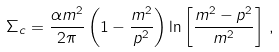<formula> <loc_0><loc_0><loc_500><loc_500>\Sigma _ { c } = \frac { \alpha m ^ { 2 } } { 2 \pi } \left ( 1 - \frac { m ^ { 2 } } { p ^ { 2 } } \right ) \ln \left [ \frac { m ^ { 2 } - p ^ { 2 } } { m ^ { 2 } } \right ] \, ,</formula> 